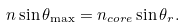<formula> <loc_0><loc_0><loc_500><loc_500>n \sin \theta _ { \max } = n _ { c o r e } \sin \theta _ { r } .</formula> 